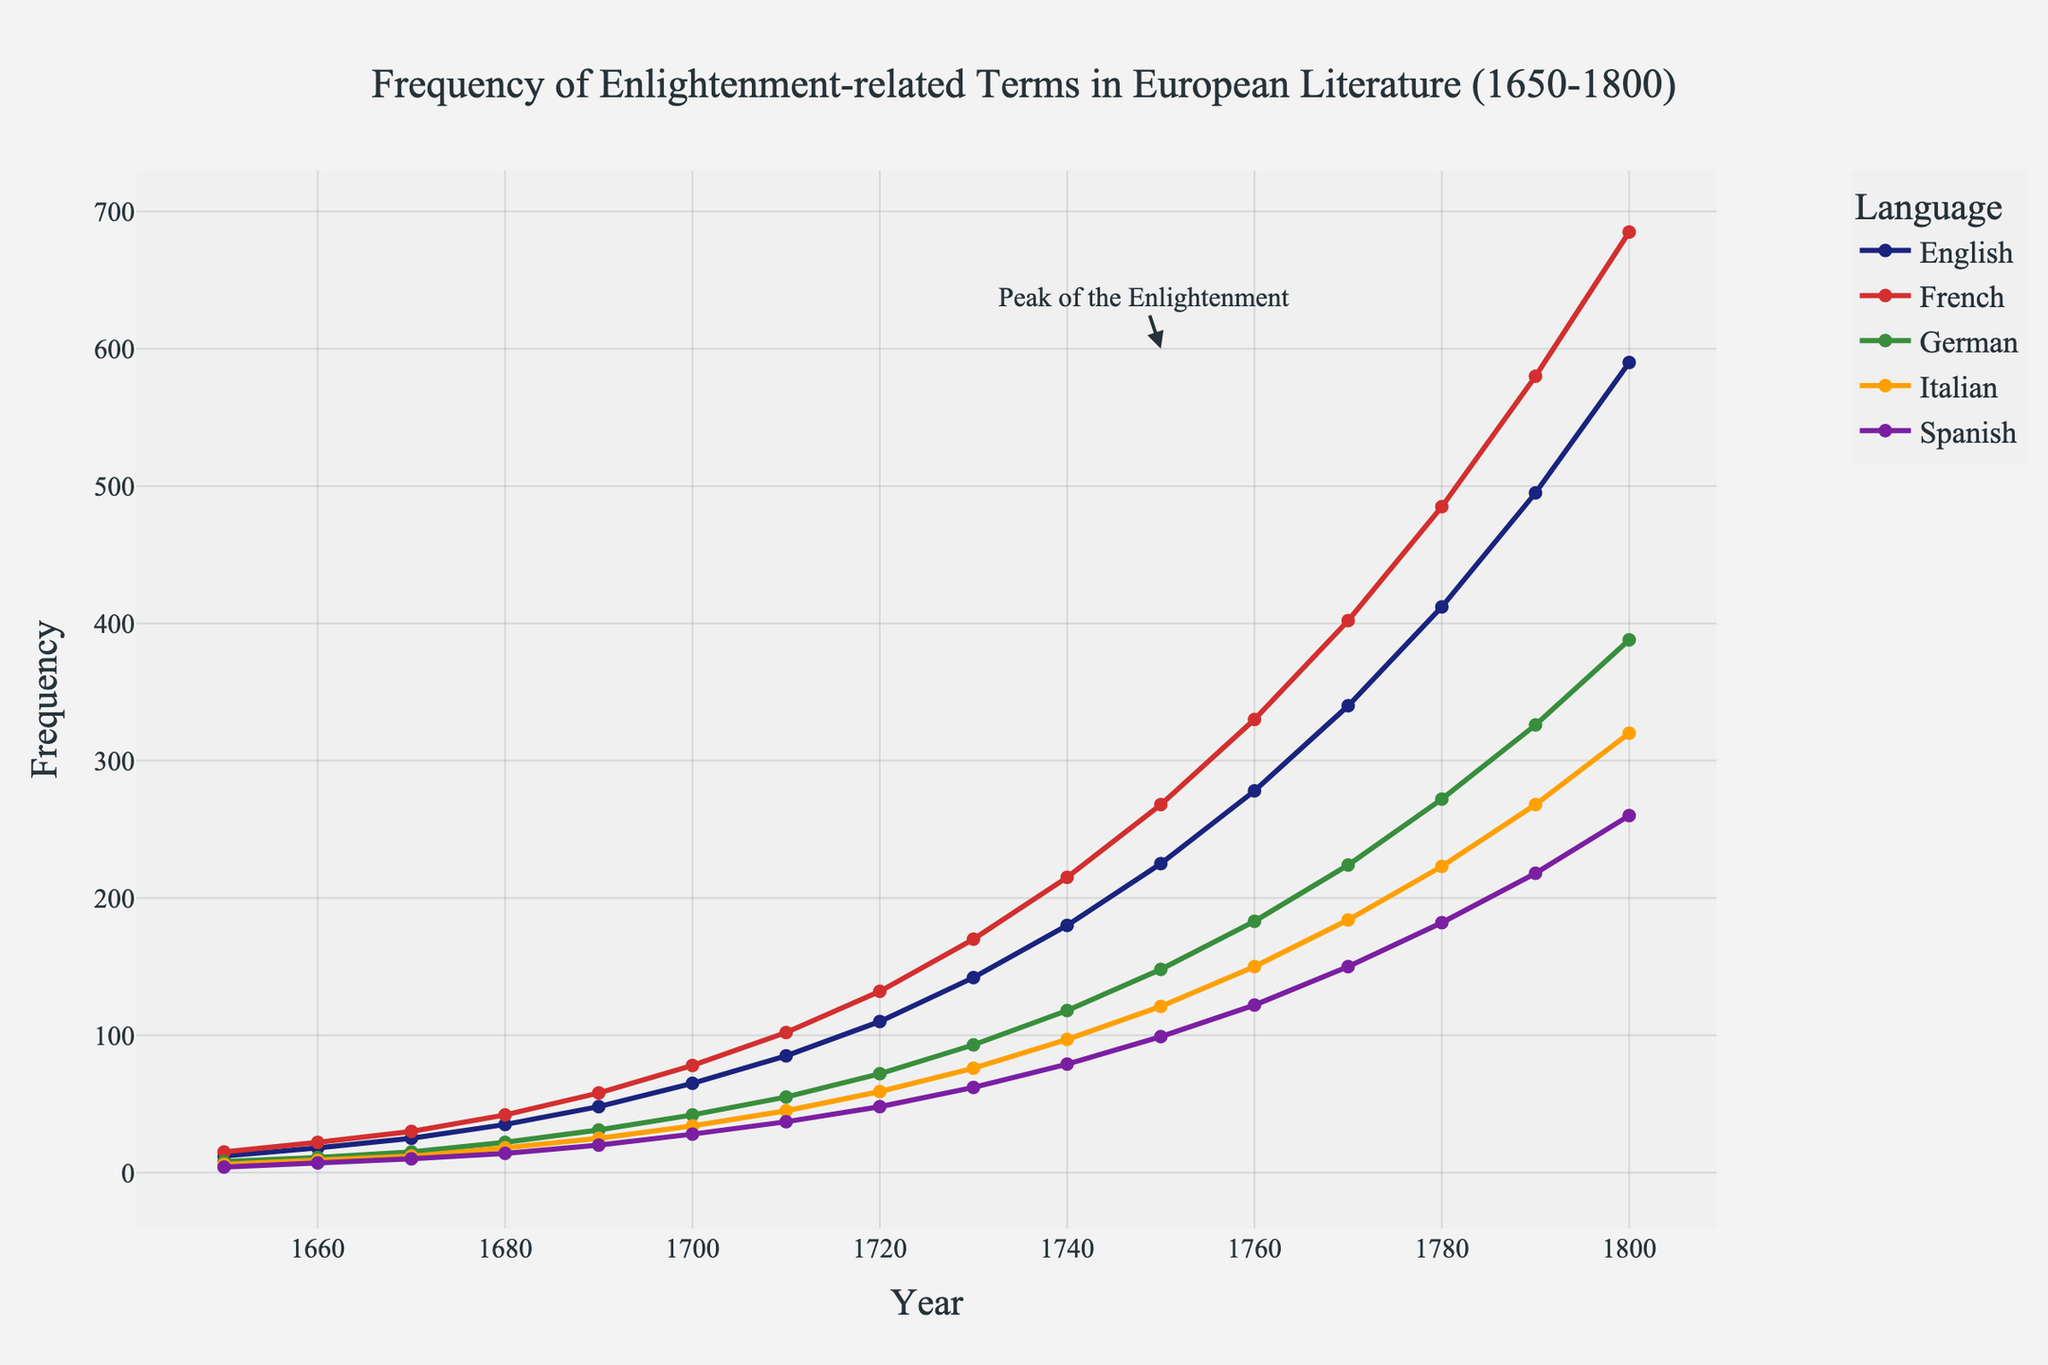What year did the frequency of Enlightenment-related terms in French literature first surpass 400? From the line chart, locate the year where the French line crosses the 400 frequency mark. The French line surpasses 400 between 1760 and 1770. From the data, 1770 is the first year the frequency is 402, surpassing 400.
Answer: 1770 In which language was the frequency of Enlightenment-related terms the highest in 1800, and what was this frequency? To find the highest frequency language in 1800, look at the endpoints of each language line at the year 1800. The English line is the highest in 1800, at a frequency of 590.
Answer: English, 590 Estimate the period with the most significant rate of frequency increase for German literature. To estimate the period with the most significant rate of frequency increase, observe the steepest slope in the line for German literature. The German line has the steepest increase between 1760 and 1790.
Answer: 1760-1790 Compare the frequency of Enlightenment-related terms between French and Italian literature in 1730. Which language had a higher frequency, and by how much? Identify 1730 on the x-axis and compare the y-values for French and Italian lines. In 1730, French has a frequency of 170 and Italian has 76. Subtract to find the difference: 170 - 76 = 94.
Answer: French, by 94 During which decade did Spanish literature see the smallest increase in the frequency of Enlightenment-related terms? Look for the smallest increase between consecutive points on the Spanish line. The smallest increase appears between 1670 and 1680, where it rose from 10 to 14 (an increase of 4).
Answer: 1670-1680 What is the average frequency of Enlightenment-related terms in English literature between 1750 and 1770? Find the frequencies in 1750, 1760, and 1770 for English: 225, 278, and 340. Calculate the average: (225 + 278 + 340) / 3 = 281.
Answer: 281 Which language had the lowest frequency of Enlightenment-related terms in 1680, and what was the frequency? Determine the lowest point among all lines at 1680. Spanish has the lowest frequency at 1680 with a value of 14.
Answer: Spanish, 14 Establish if there was any decade where the Italian literature's frequency of Enlightenment-related terms doubled and support your answer using the data. Doubling means the frequency becomes twice its previous value. Compare data for Italian literature: it doubled from 18 in 1680 to 34 in 1700 (nearly doubled as 34/18 = 1.89). No decade shows exact doubling.
Answer: No Which period saw the highest overall frequency increase across all languages, and how much was the increase? Evaluate total increase across all languages for each period: (sum frequencies at 1800 - sum at 1650). The overall highest increase occurs from 1770 to 1780: from 1080 to 1574, with an increase of 494.
Answer: 1770-1780, 494 